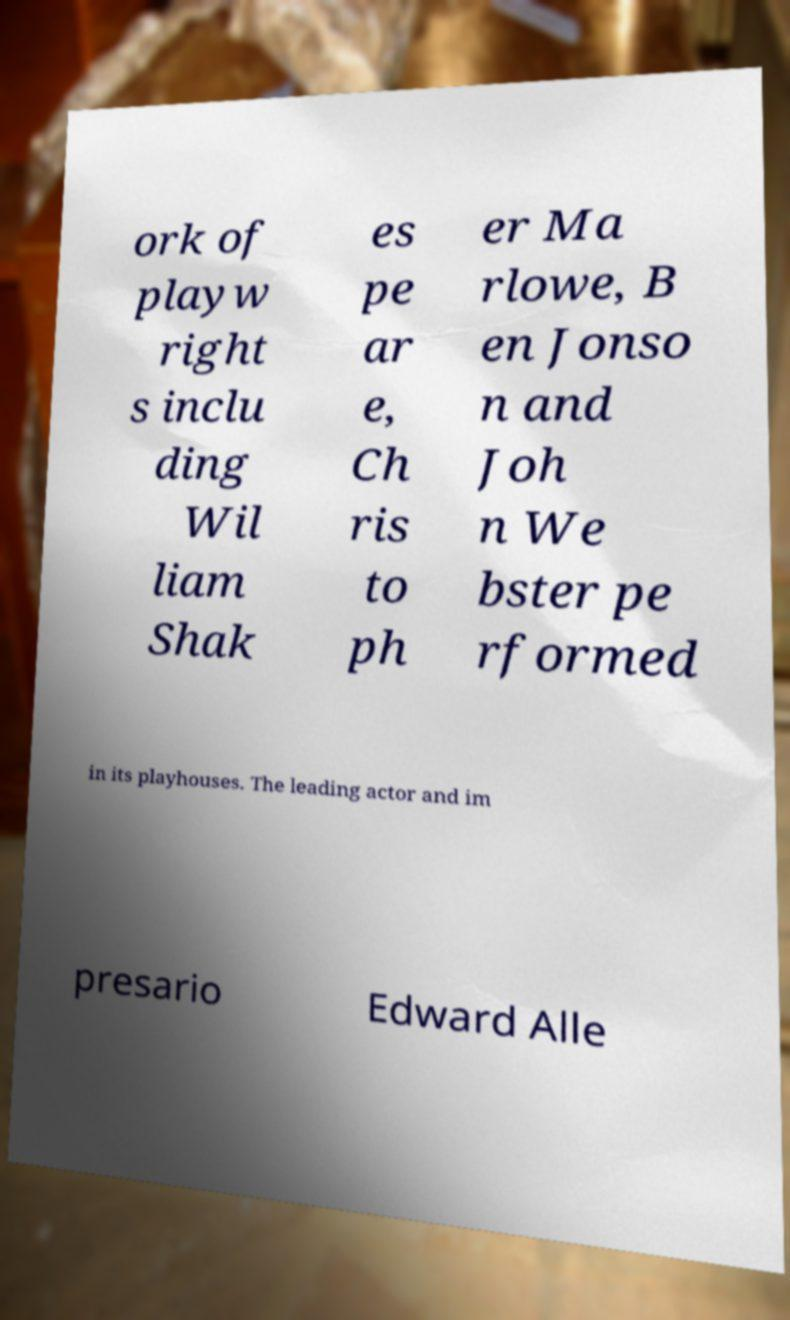Please read and relay the text visible in this image. What does it say? ork of playw right s inclu ding Wil liam Shak es pe ar e, Ch ris to ph er Ma rlowe, B en Jonso n and Joh n We bster pe rformed in its playhouses. The leading actor and im presario Edward Alle 